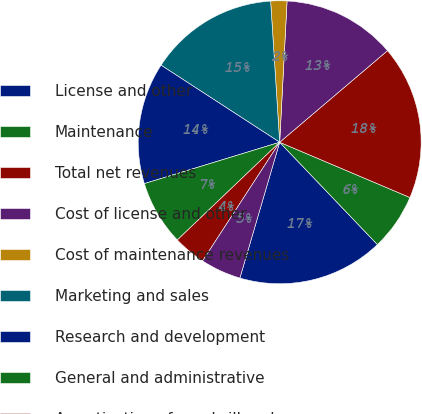Convert chart. <chart><loc_0><loc_0><loc_500><loc_500><pie_chart><fcel>License and other<fcel>Maintenance<fcel>Total net revenues<fcel>Cost of license and other<fcel>Cost of maintenance revenues<fcel>Marketing and sales<fcel>Research and development<fcel>General and administrative<fcel>Amortization of goodwill and<fcel>Restructuring and other<nl><fcel>16.67%<fcel>6.48%<fcel>17.59%<fcel>12.96%<fcel>1.85%<fcel>14.81%<fcel>13.89%<fcel>7.41%<fcel>3.7%<fcel>4.63%<nl></chart> 